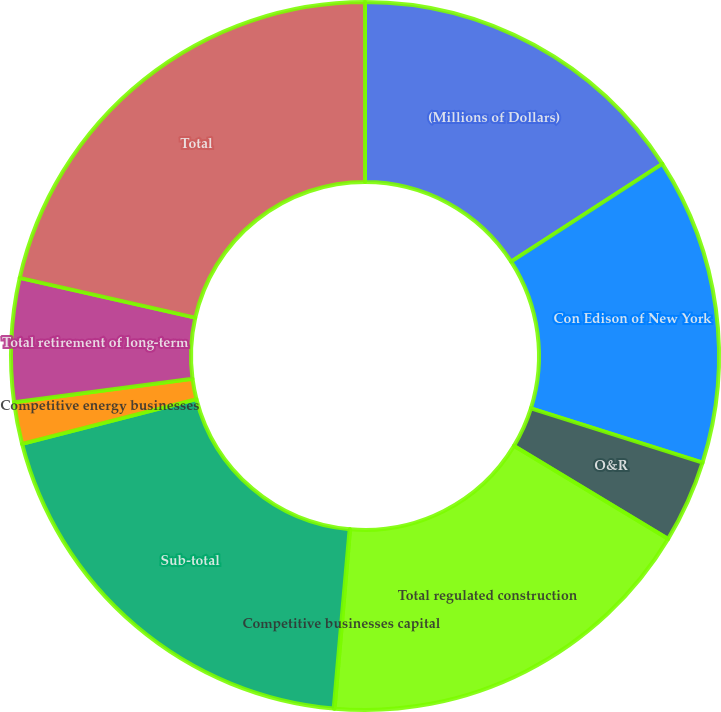Convert chart. <chart><loc_0><loc_0><loc_500><loc_500><pie_chart><fcel>(Millions of Dollars)<fcel>Con Edison of New York<fcel>O&R<fcel>Total regulated construction<fcel>Competitive businesses capital<fcel>Sub-total<fcel>Competitive energy businesses<fcel>Total retirement of long-term<fcel>Total<nl><fcel>15.87%<fcel>14.0%<fcel>3.77%<fcel>17.73%<fcel>0.04%<fcel>19.6%<fcel>1.9%<fcel>5.63%<fcel>21.46%<nl></chart> 